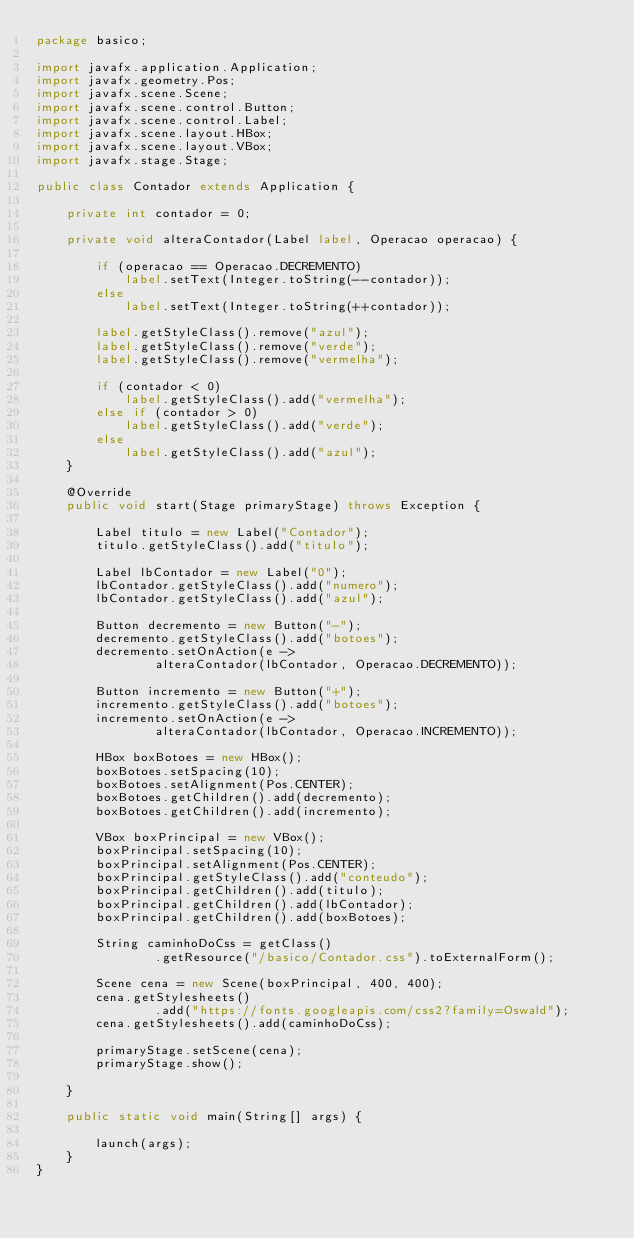Convert code to text. <code><loc_0><loc_0><loc_500><loc_500><_Java_>package basico;

import javafx.application.Application;
import javafx.geometry.Pos;
import javafx.scene.Scene;
import javafx.scene.control.Button;
import javafx.scene.control.Label;
import javafx.scene.layout.HBox;
import javafx.scene.layout.VBox;
import javafx.stage.Stage;

public class Contador extends Application {
	
	private int contador = 0;
	
	private void alteraContador(Label label, Operacao operacao) {
		
		if (operacao == Operacao.DECREMENTO)
			label.setText(Integer.toString(--contador));
		else
			label.setText(Integer.toString(++contador));
		
		label.getStyleClass().remove("azul");
		label.getStyleClass().remove("verde");
		label.getStyleClass().remove("vermelha");
		
		if (contador < 0)
			label.getStyleClass().add("vermelha");
		else if (contador > 0)
			label.getStyleClass().add("verde");
		else
			label.getStyleClass().add("azul");
	}

	@Override
	public void start(Stage primaryStage) throws Exception {
		
		Label titulo = new Label("Contador");
		titulo.getStyleClass().add("titulo");
		
		Label lbContador = new Label("0");
		lbContador.getStyleClass().add("numero");
		lbContador.getStyleClass().add("azul");
				
		Button decremento = new Button("-");
		decremento.getStyleClass().add("botoes");
		decremento.setOnAction(e ->
				alteraContador(lbContador, Operacao.DECREMENTO));
		
		Button incremento = new Button("+");
		incremento.getStyleClass().add("botoes");
		incremento.setOnAction(e ->
				alteraContador(lbContador, Operacao.INCREMENTO));
		
		HBox boxBotoes = new HBox();
		boxBotoes.setSpacing(10);
		boxBotoes.setAlignment(Pos.CENTER);
		boxBotoes.getChildren().add(decremento);
		boxBotoes.getChildren().add(incremento);
		
		VBox boxPrincipal = new VBox();
		boxPrincipal.setSpacing(10);
		boxPrincipal.setAlignment(Pos.CENTER);
		boxPrincipal.getStyleClass().add("conteudo");
		boxPrincipal.getChildren().add(titulo);
		boxPrincipal.getChildren().add(lbContador);
		boxPrincipal.getChildren().add(boxBotoes);
		
		String caminhoDoCss = getClass()
				.getResource("/basico/Contador.css").toExternalForm();
		
		Scene cena = new Scene(boxPrincipal, 400, 400);
		cena.getStylesheets()
				.add("https://fonts.googleapis.com/css2?family=Oswald");
		cena.getStylesheets().add(caminhoDoCss);
		
		primaryStage.setScene(cena);
		primaryStage.show();
		
	}
	
	public static void main(String[] args) {
		
		launch(args);
	}
}
</code> 